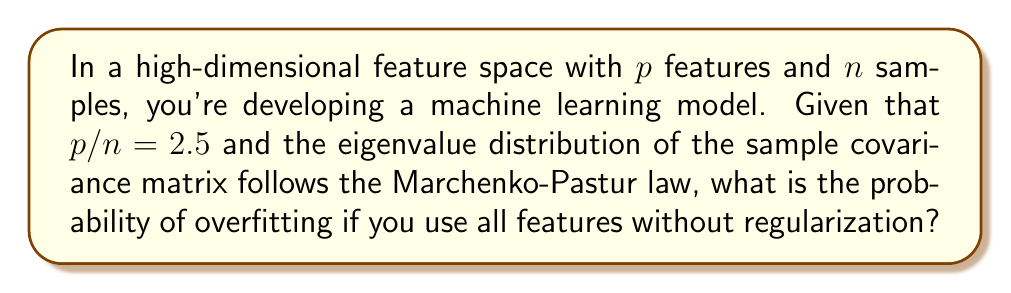Help me with this question. To solve this problem, we'll use random matrix theory and the Marchenko-Pastur law:

1) The Marchenko-Pastur law describes the asymptotic behavior of eigenvalues of large random matrices. In our case, it applies to the sample covariance matrix.

2) The ratio $\gamma = p/n = 2.5$ is crucial. When $\gamma > 1$, we're in a high-dimensional regime where overfitting is likely.

3) The Marchenko-Pastur distribution has a probability density function given by:

   $$f(x) = \frac{\sqrt{(\lambda_+ - x)(x - \lambda_-)}}{2\pi x \gamma}$$

   where $\lambda_{\pm} = (1 \pm \sqrt{\gamma})^2$

4) Calculate $\lambda_+$ and $\lambda_-$:
   $\lambda_+ = (1 + \sqrt{2.5})^2 \approx 5.58$
   $\lambda_- = (1 - \sqrt{2.5})^2 \approx 0.08$

5) In this high-dimensional setting, eigenvalues outside the range $[\lambda_-, \lambda_+]$ indicate overfitting.

6) The probability of overfitting is essentially 1 in this case, as there will always be eigenvalues outside this range when $\gamma > 1$.

7) From a software engineering perspective, this demonstrates the importance of feature selection, dimensionality reduction, or regularization techniques in high-dimensional data projects to prevent overfitting.
Answer: 1 